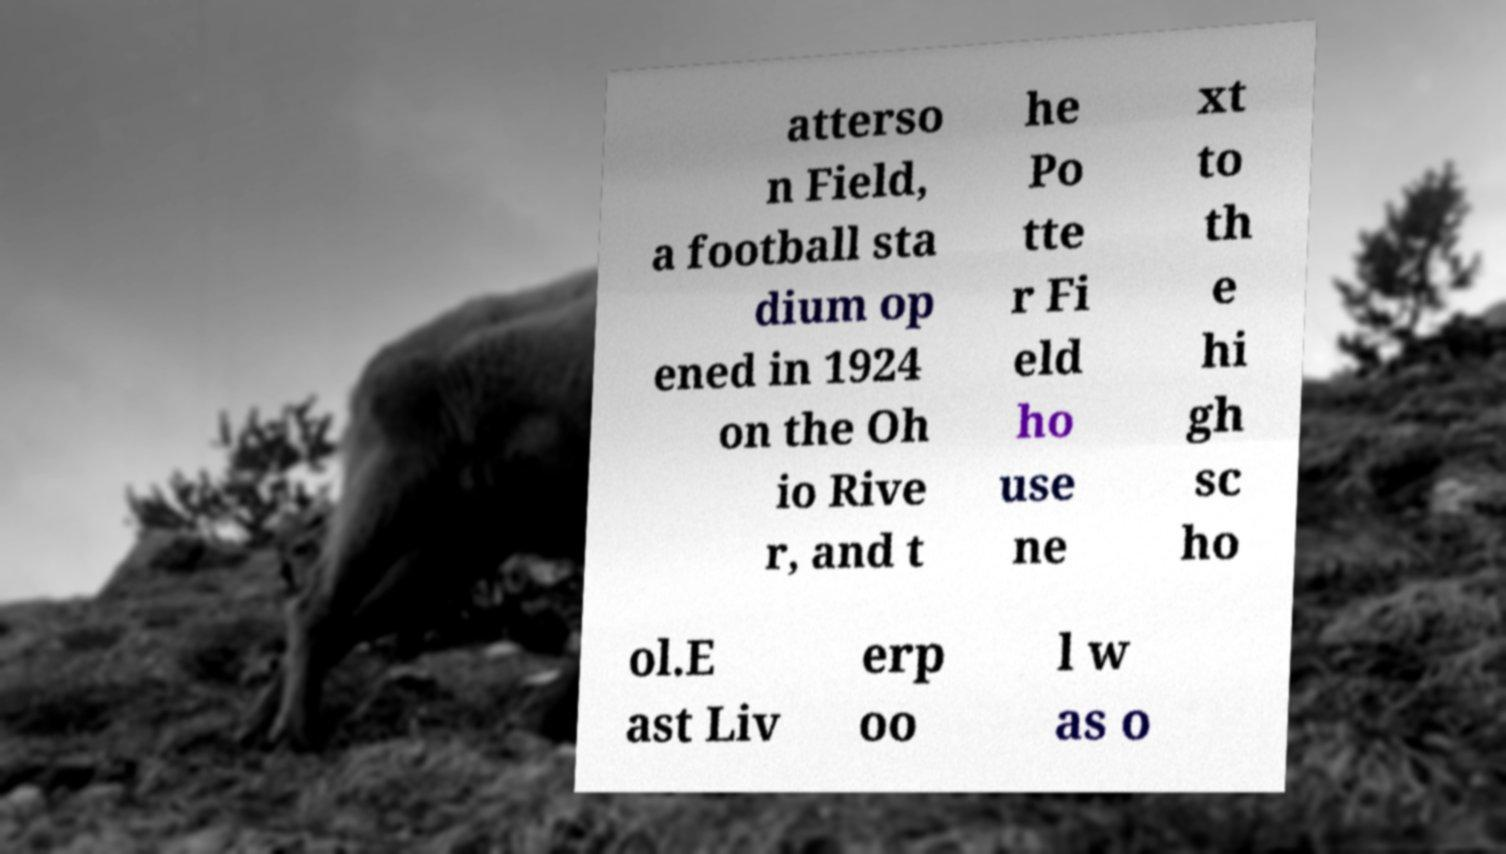Can you read and provide the text displayed in the image?This photo seems to have some interesting text. Can you extract and type it out for me? atterso n Field, a football sta dium op ened in 1924 on the Oh io Rive r, and t he Po tte r Fi eld ho use ne xt to th e hi gh sc ho ol.E ast Liv erp oo l w as o 